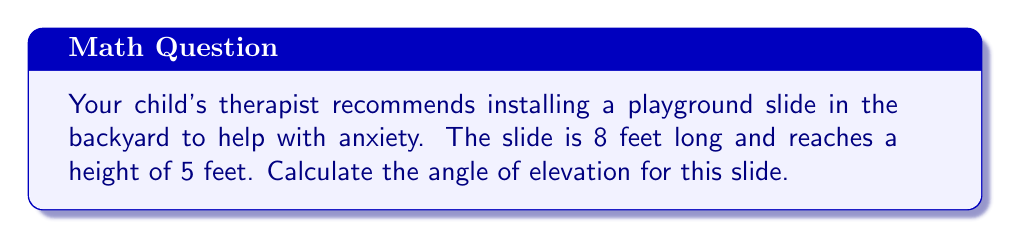Help me with this question. Let's approach this step-by-step:

1) We can visualize the slide as the hypotenuse of a right triangle. The height of the slide forms the opposite side, and the horizontal distance forms the adjacent side.

2) We know:
   - The length of the slide (hypotenuse) = 8 feet
   - The height of the slide (opposite) = 5 feet

3) To find the angle of elevation, we need to use the inverse sine (arcsin) function.

4) In a right triangle, $\sin(\theta) = \frac{\text{opposite}}{\text{hypotenuse}}$

5) Plugging in our values:

   $\sin(\theta) = \frac{5}{8}$

6) To solve for $\theta$, we take the inverse sine of both sides:

   $\theta = \arcsin(\frac{5}{8})$

7) Using a calculator or trigonometric tables:

   $\theta \approx 38.68^\circ$

[asy]
import geometry;

pair A=(0,0), B=(6,5), C=(6,0);
draw(A--B--C--A);
draw(rightanglemark(A,C,B,2));
label("8'", (A+B)/2, NW);
label("5'", (B+C)/2, E);
label("$\theta$", A, SW);
[/asy]
Answer: $38.68^\circ$ 